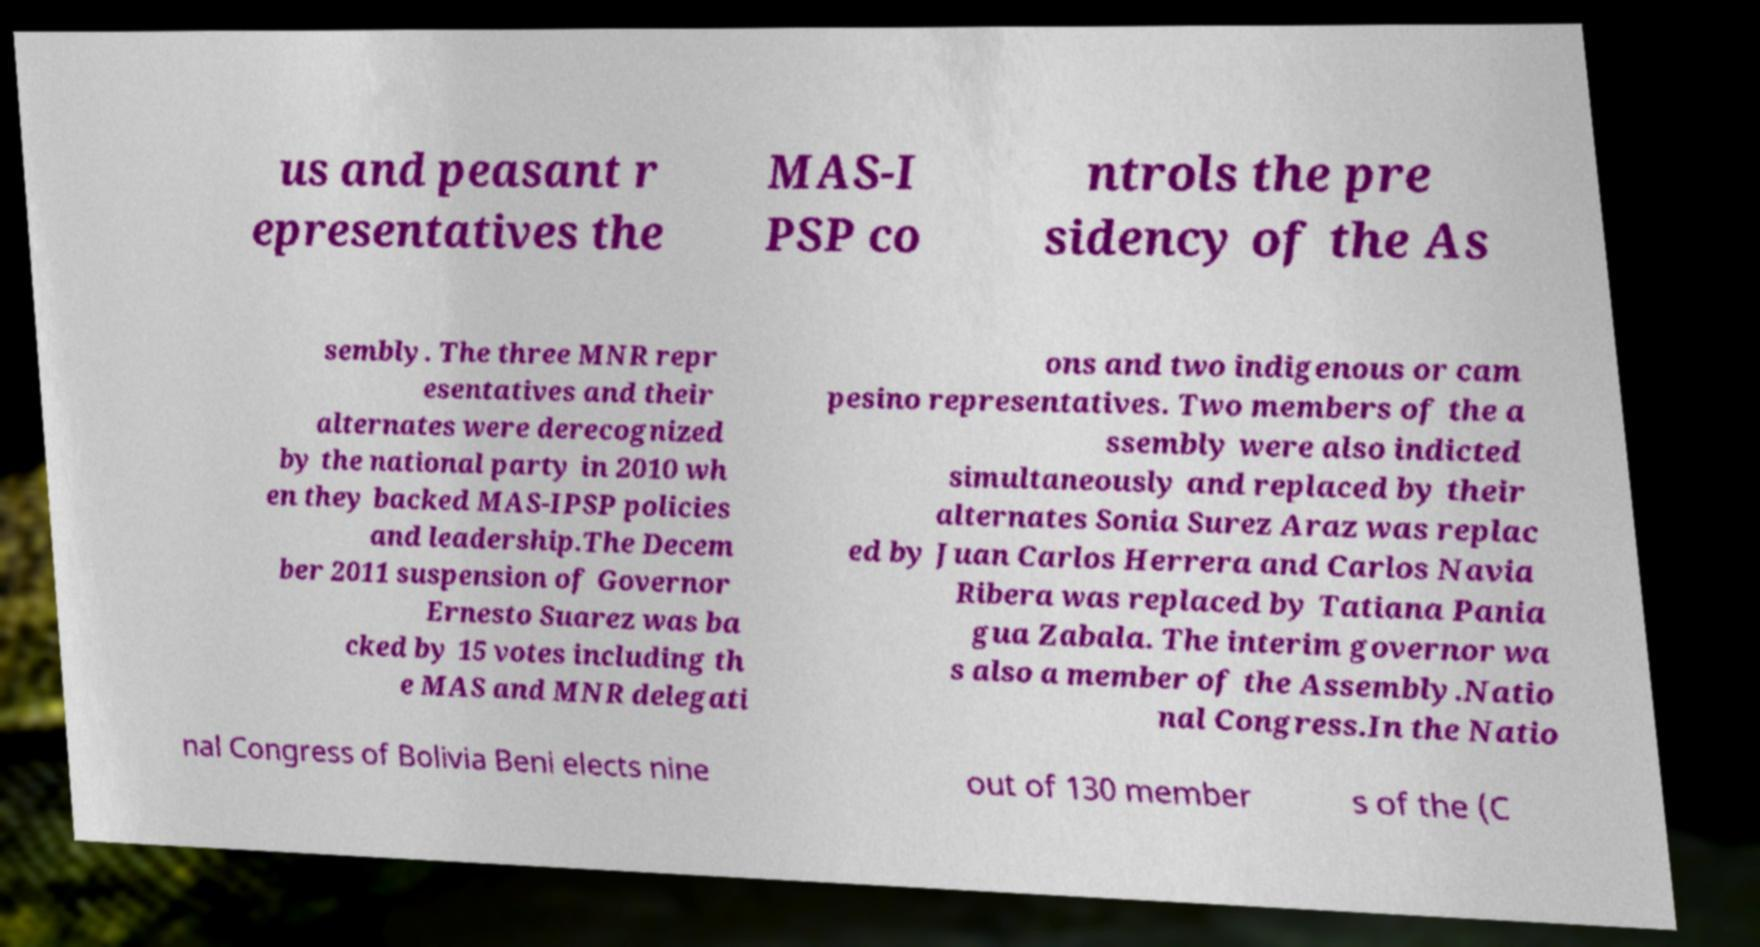Could you assist in decoding the text presented in this image and type it out clearly? us and peasant r epresentatives the MAS-I PSP co ntrols the pre sidency of the As sembly. The three MNR repr esentatives and their alternates were derecognized by the national party in 2010 wh en they backed MAS-IPSP policies and leadership.The Decem ber 2011 suspension of Governor Ernesto Suarez was ba cked by 15 votes including th e MAS and MNR delegati ons and two indigenous or cam pesino representatives. Two members of the a ssembly were also indicted simultaneously and replaced by their alternates Sonia Surez Araz was replac ed by Juan Carlos Herrera and Carlos Navia Ribera was replaced by Tatiana Pania gua Zabala. The interim governor wa s also a member of the Assembly.Natio nal Congress.In the Natio nal Congress of Bolivia Beni elects nine out of 130 member s of the (C 